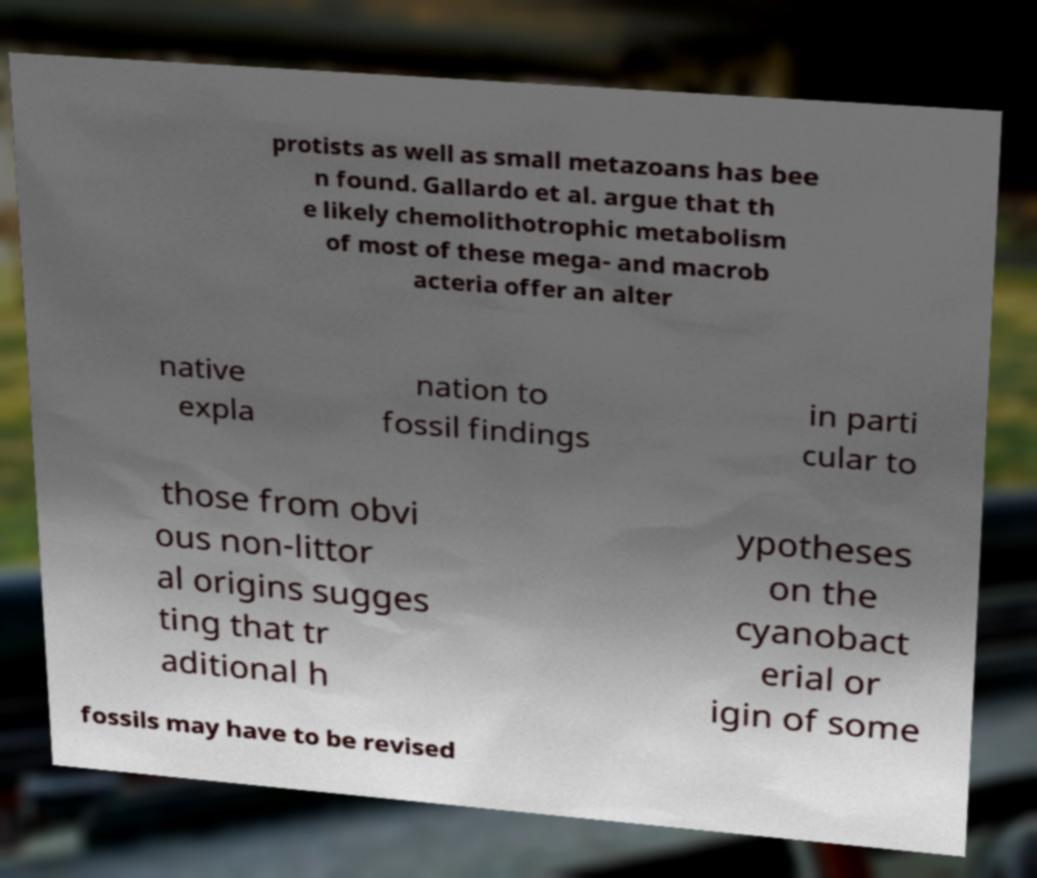Can you accurately transcribe the text from the provided image for me? protists as well as small metazoans has bee n found. Gallardo et al. argue that th e likely chemolithotrophic metabolism of most of these mega- and macrob acteria offer an alter native expla nation to fossil findings in parti cular to those from obvi ous non-littor al origins sugges ting that tr aditional h ypotheses on the cyanobact erial or igin of some fossils may have to be revised 